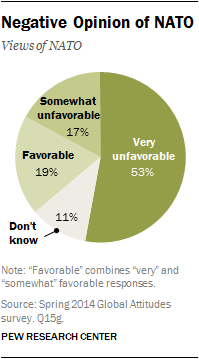Specify some key components in this picture. The value of very unfavourable in a pie graph is 53. 